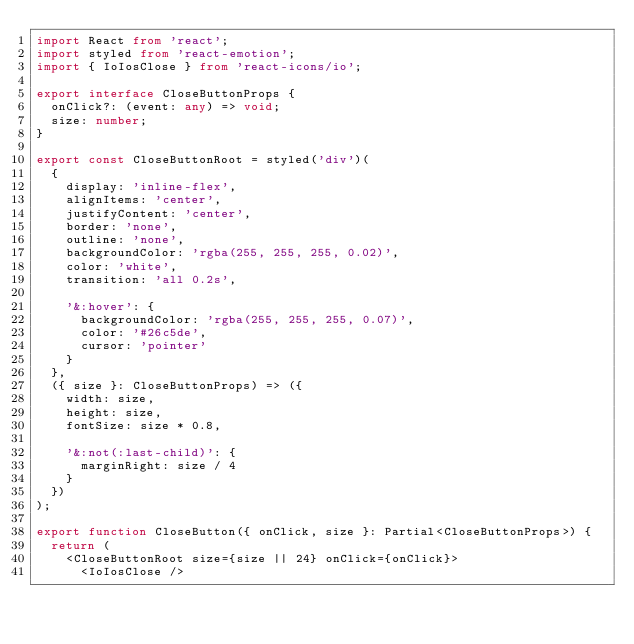Convert code to text. <code><loc_0><loc_0><loc_500><loc_500><_TypeScript_>import React from 'react';
import styled from 'react-emotion';
import { IoIosClose } from 'react-icons/io';

export interface CloseButtonProps {
  onClick?: (event: any) => void;
  size: number;
}

export const CloseButtonRoot = styled('div')(
  {
    display: 'inline-flex',
    alignItems: 'center',
    justifyContent: 'center',
    border: 'none',
    outline: 'none',
    backgroundColor: 'rgba(255, 255, 255, 0.02)',
    color: 'white',
    transition: 'all 0.2s',

    '&:hover': {
      backgroundColor: 'rgba(255, 255, 255, 0.07)',
      color: '#26c5de',
      cursor: 'pointer'
    }
  },
  ({ size }: CloseButtonProps) => ({
    width: size,
    height: size,
    fontSize: size * 0.8,

    '&:not(:last-child)': {
      marginRight: size / 4
    }
  })
);

export function CloseButton({ onClick, size }: Partial<CloseButtonProps>) {
  return (
    <CloseButtonRoot size={size || 24} onClick={onClick}>
      <IoIosClose /></code> 